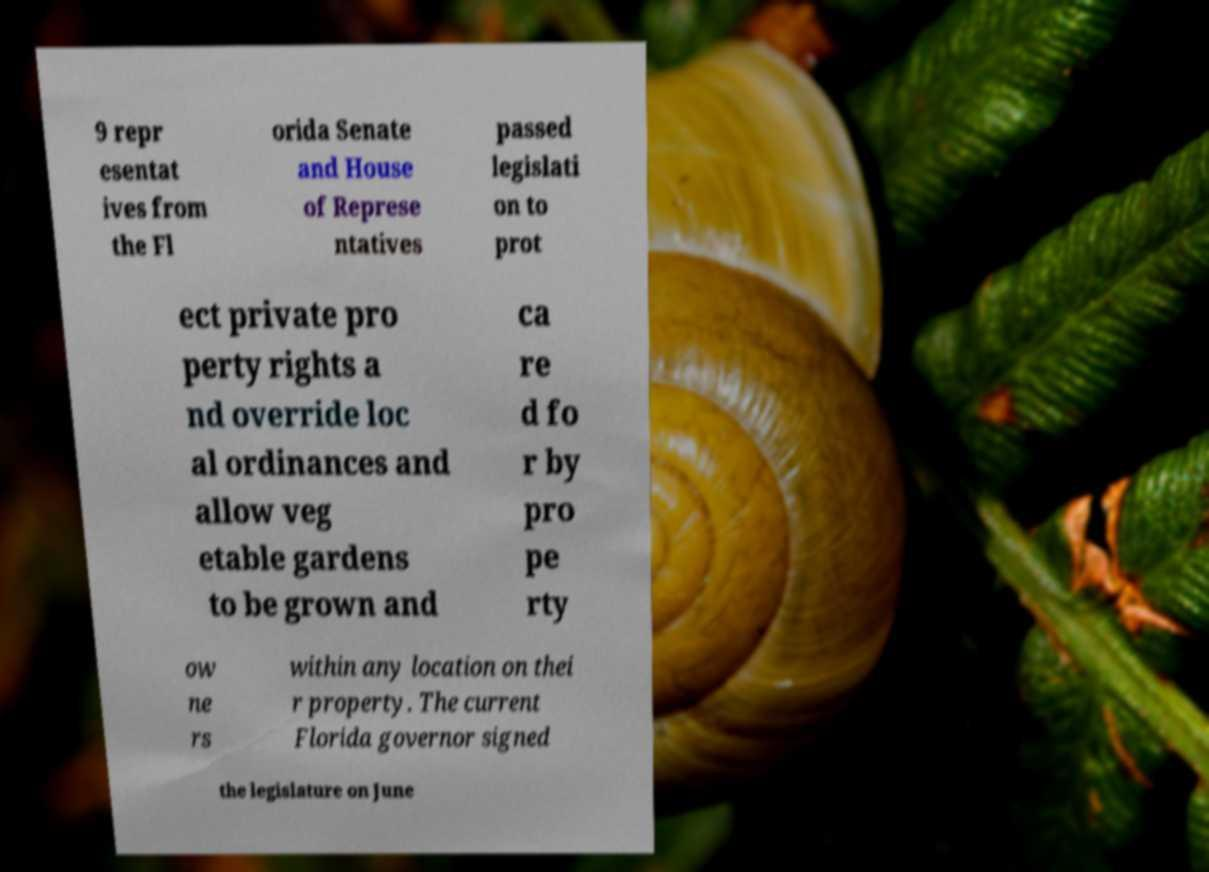Please identify and transcribe the text found in this image. 9 repr esentat ives from the Fl orida Senate and House of Represe ntatives passed legislati on to prot ect private pro perty rights a nd override loc al ordinances and allow veg etable gardens to be grown and ca re d fo r by pro pe rty ow ne rs within any location on thei r property. The current Florida governor signed the legislature on June 